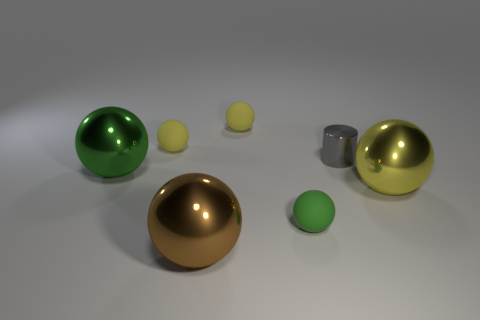There is a green thing that is the same material as the tiny gray thing; what is its size?
Your answer should be very brief. Large. Is there anything else that is the same color as the cylinder?
Offer a terse response. No. There is a object that is in front of the small green matte thing; is its color the same as the metal sphere that is on the right side of the small green thing?
Offer a very short reply. No. The large sphere right of the green matte sphere is what color?
Your response must be concise. Yellow. There is a yellow object in front of the green metal sphere; is it the same size as the small green ball?
Give a very brief answer. No. Is the number of small metal cylinders less than the number of small purple rubber balls?
Your answer should be compact. No. There is a tiny shiny thing; what number of tiny balls are in front of it?
Your answer should be very brief. 1. Is the shape of the large green object the same as the brown metallic thing?
Your answer should be compact. Yes. How many spheres are both behind the tiny gray thing and on the right side of the small shiny cylinder?
Give a very brief answer. 0. What number of things are small metal things or tiny things that are behind the large yellow metal sphere?
Your answer should be very brief. 3. 